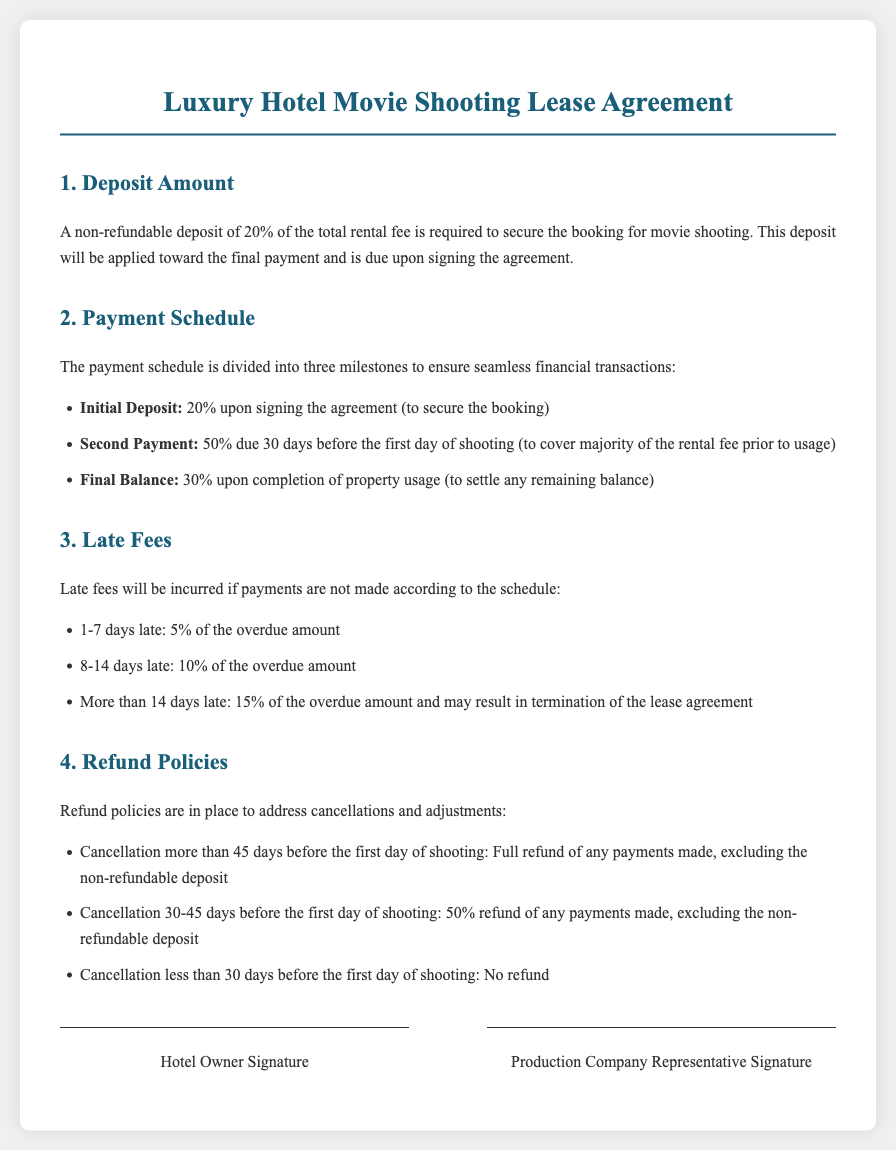What is the non-refundable deposit percentage? The document states that a non-refundable deposit of 20% is required to secure the booking.
Answer: 20% When is the second payment due? According to the payment schedule, the second payment of 50% is due 30 days before the first day of shooting.
Answer: 30 days before What happens if the payment is 1-7 days late? The document specifies a late fee of 5% of the overdue amount for payments that are 1-7 days late.
Answer: 5% What is the refund policy for cancellation more than 45 days before shooting? The document states that if a cancellation occurs more than 45 days before shooting, a full refund (excluding the deposit) will be issued.
Answer: Full refund What portion of the rental fee is due upon completion? The final balance is specified as 30% of the total rental fee, which is due upon completion of property usage.
Answer: 30% 